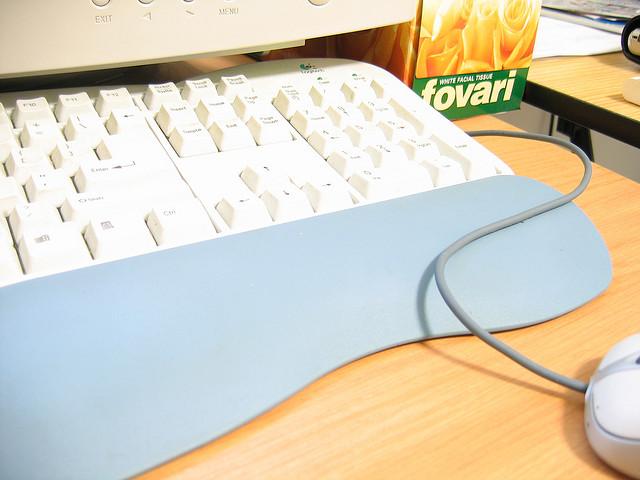What is favori?
Give a very brief answer. Tissues. How many objects are there?
Keep it brief. 6. What color is the keyboard?
Answer briefly. White. 